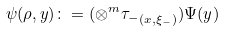Convert formula to latex. <formula><loc_0><loc_0><loc_500><loc_500>\psi ( \rho , y ) \colon = ( \otimes ^ { m } { \tau _ { - } } _ { ( x , \xi _ { - } ) } ) \Psi ( y )</formula> 